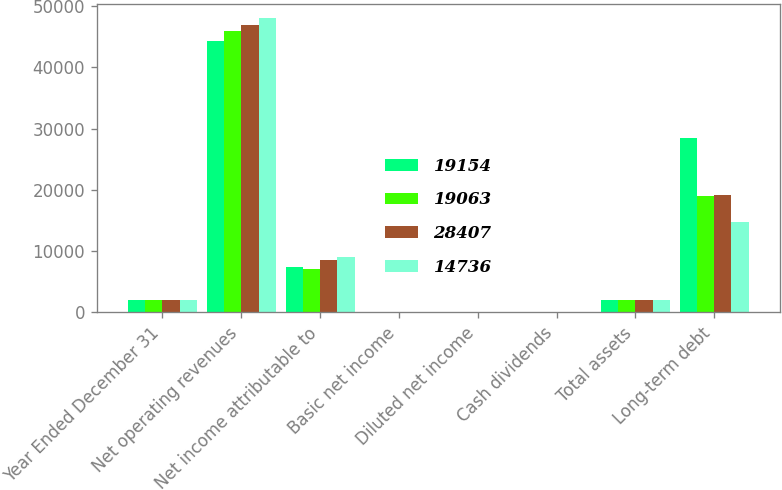<chart> <loc_0><loc_0><loc_500><loc_500><stacked_bar_chart><ecel><fcel>Year Ended December 31<fcel>Net operating revenues<fcel>Net income attributable to<fcel>Basic net income<fcel>Diluted net income<fcel>Cash dividends<fcel>Total assets<fcel>Long-term debt<nl><fcel>19154<fcel>2015<fcel>44294<fcel>7351<fcel>1.69<fcel>1.67<fcel>1.32<fcel>2013.5<fcel>28407<nl><fcel>19063<fcel>2014<fcel>45998<fcel>7098<fcel>1.62<fcel>1.6<fcel>1.22<fcel>2013.5<fcel>19063<nl><fcel>28407<fcel>2013<fcel>46854<fcel>8584<fcel>1.94<fcel>1.9<fcel>1.12<fcel>2013.5<fcel>19154<nl><fcel>14736<fcel>2012<fcel>48017<fcel>9019<fcel>2<fcel>1.97<fcel>1.02<fcel>2013.5<fcel>14736<nl></chart> 